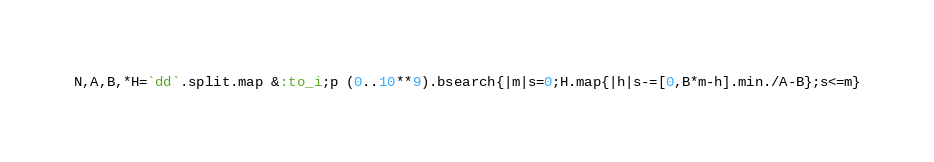<code> <loc_0><loc_0><loc_500><loc_500><_Ruby_>N,A,B,*H=`dd`.split.map &:to_i;p (0..10**9).bsearch{|m|s=0;H.map{|h|s-=[0,B*m-h].min./A-B};s<=m}</code> 